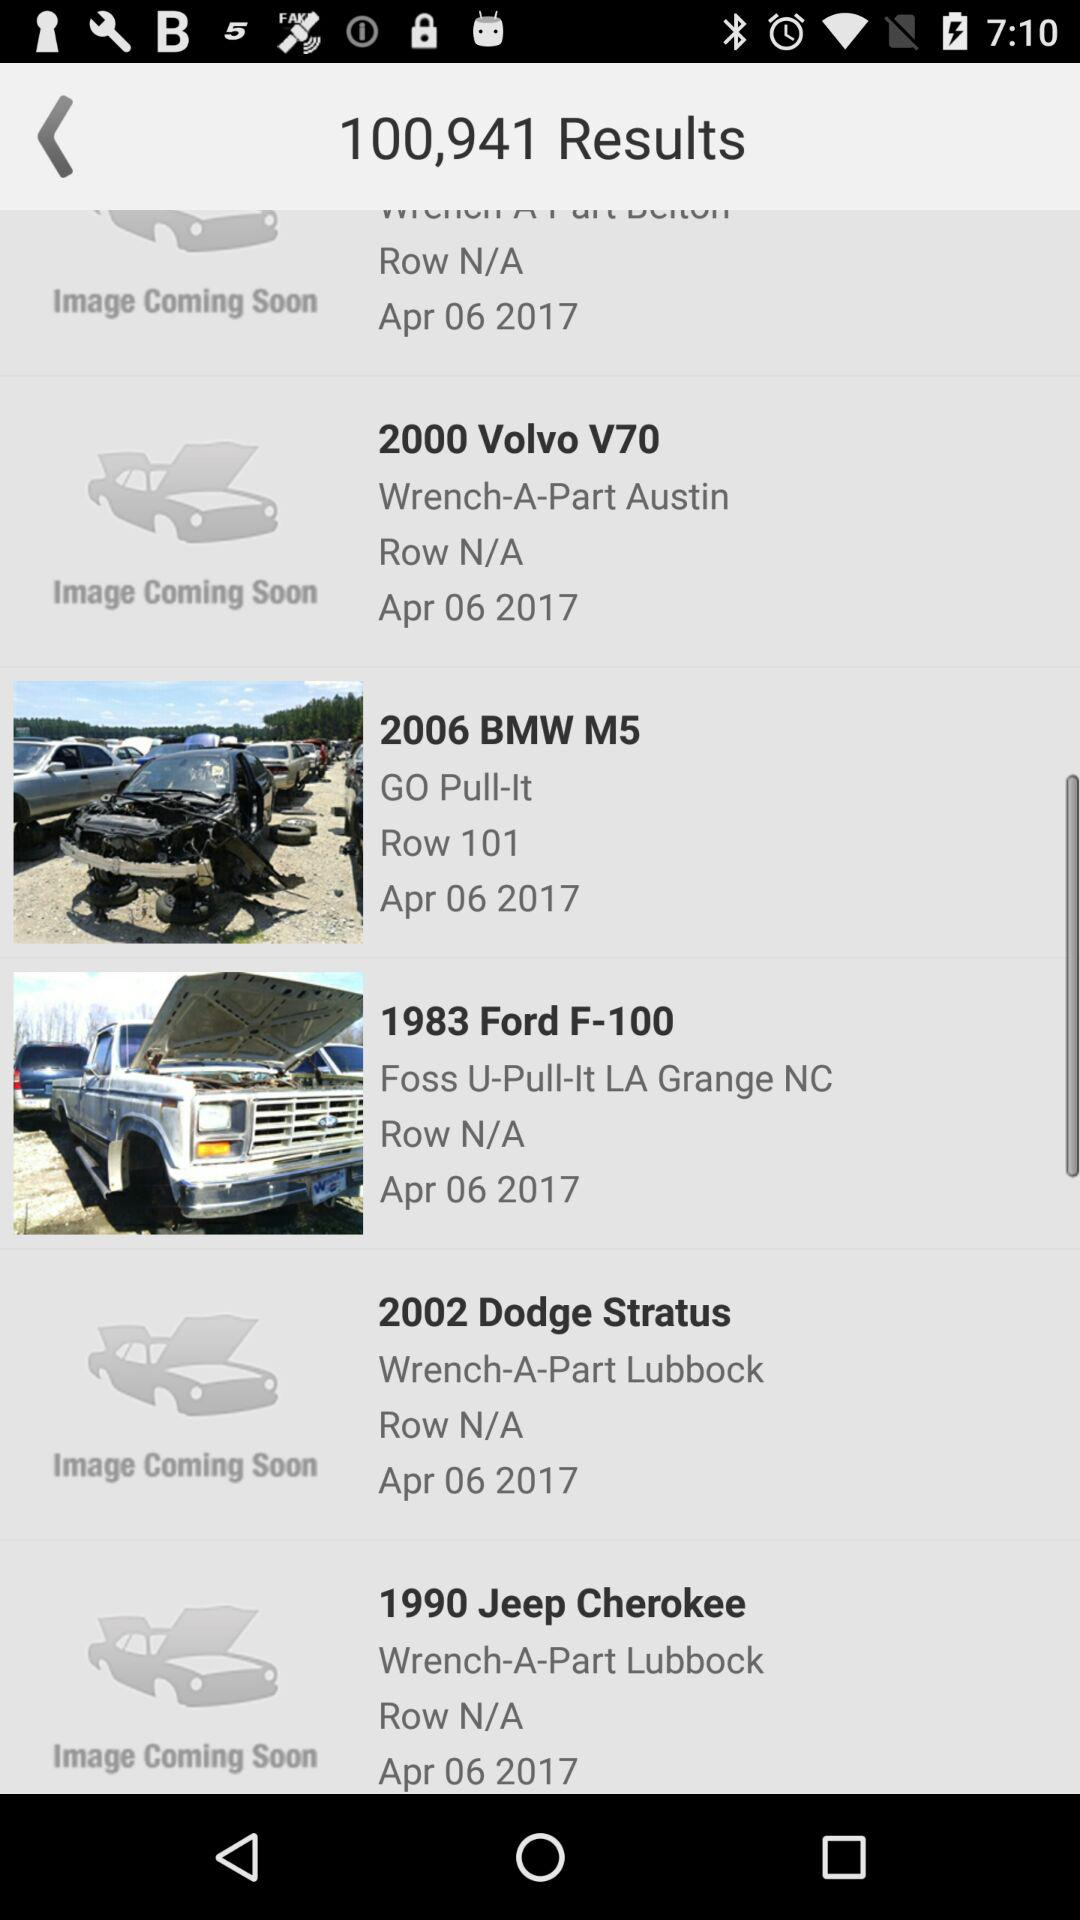What is the publication date of the 2006 BMW M5? The publication date is April 6, 2017. 